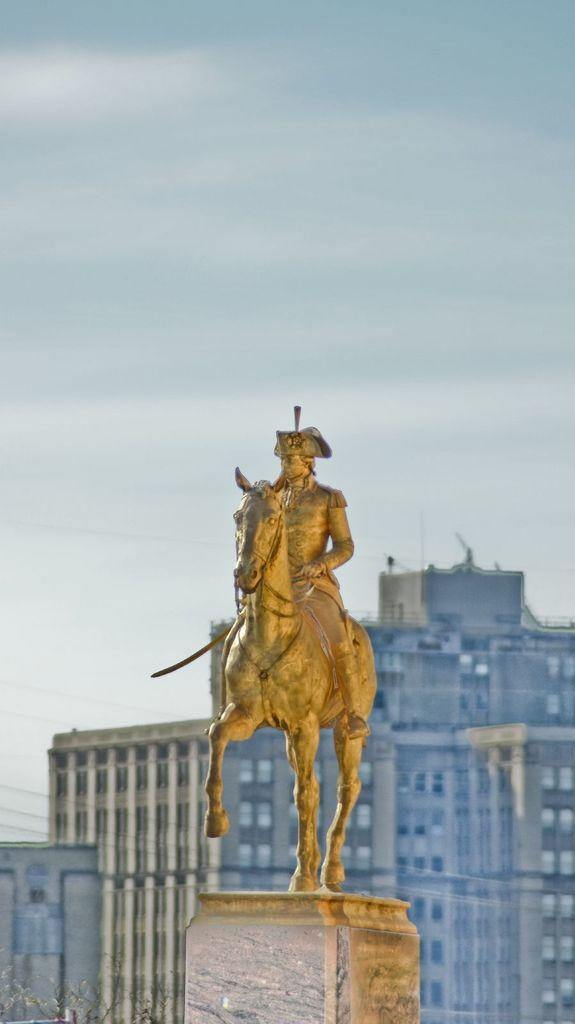What is the main subject of the image? The main subject of the image is a statue of a person. How is the person depicted in the statue? The person is depicted as sitting on a horse. What can be seen in the background of the image? There are buildings visible behind the statue. What type of wine is being served at the event in the image? There is no event or wine present in the image; it features a statue of a person sitting on a horse with buildings in the background. 